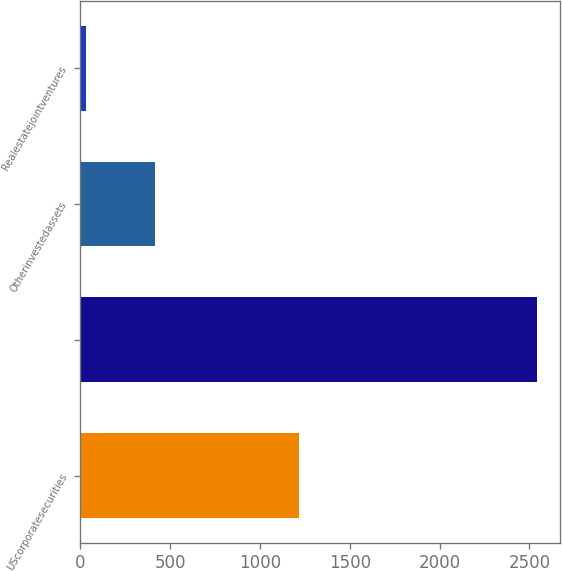Convert chart. <chart><loc_0><loc_0><loc_500><loc_500><bar_chart><fcel>UScorporatesecurities<fcel>Unnamed: 1<fcel>Otherinvestedassets<fcel>Realestatejointventures<nl><fcel>1216<fcel>2543<fcel>416<fcel>30<nl></chart> 